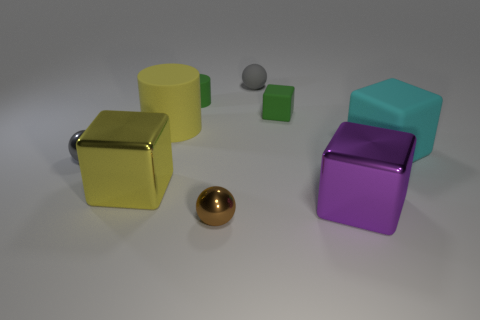Subtract all yellow blocks. How many blocks are left? 3 Subtract all gray balls. How many balls are left? 1 Subtract 3 spheres. How many spheres are left? 0 Subtract all spheres. How many objects are left? 6 Subtract all green cubes. Subtract all big metal cubes. How many objects are left? 6 Add 7 tiny metallic spheres. How many tiny metallic spheres are left? 9 Add 5 purple objects. How many purple objects exist? 6 Subtract 1 brown balls. How many objects are left? 8 Subtract all green cylinders. Subtract all green spheres. How many cylinders are left? 1 Subtract all red cubes. How many green cylinders are left? 1 